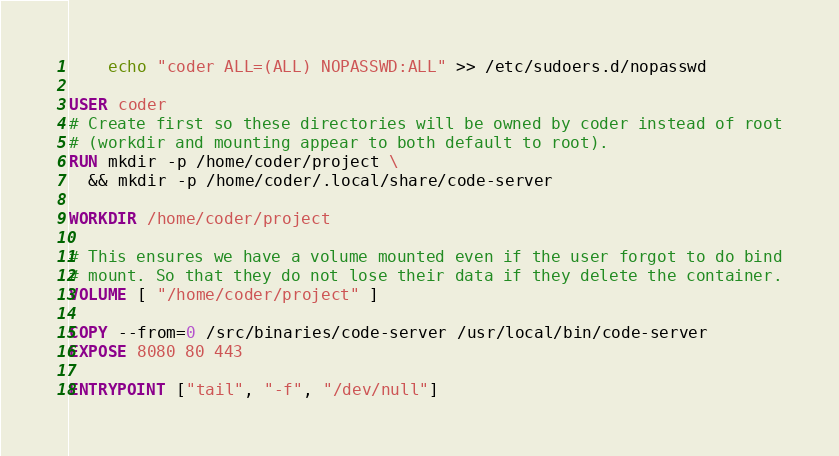Convert code to text. <code><loc_0><loc_0><loc_500><loc_500><_Dockerfile_>	echo "coder ALL=(ALL) NOPASSWD:ALL" >> /etc/sudoers.d/nopasswd

USER coder
# Create first so these directories will be owned by coder instead of root
# (workdir and mounting appear to both default to root).
RUN mkdir -p /home/coder/project \
  && mkdir -p /home/coder/.local/share/code-server

WORKDIR /home/coder/project

# This ensures we have a volume mounted even if the user forgot to do bind
# mount. So that they do not lose their data if they delete the container.
VOLUME [ "/home/coder/project" ]

COPY --from=0 /src/binaries/code-server /usr/local/bin/code-server
EXPOSE 8080 80 443

ENTRYPOINT ["tail", "-f", "/dev/null"]</code> 